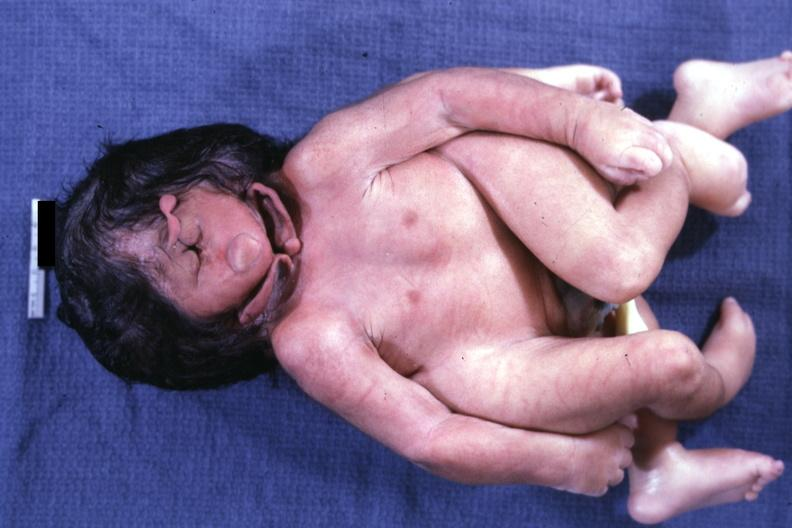what is present?
Answer the question using a single word or phrase. Conjoined twins cephalothoracopagus janiceps 